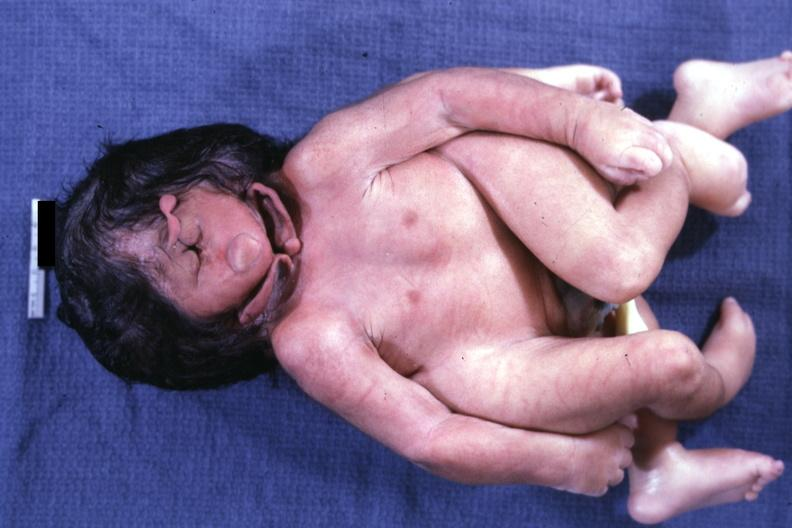what is present?
Answer the question using a single word or phrase. Conjoined twins cephalothoracopagus janiceps 